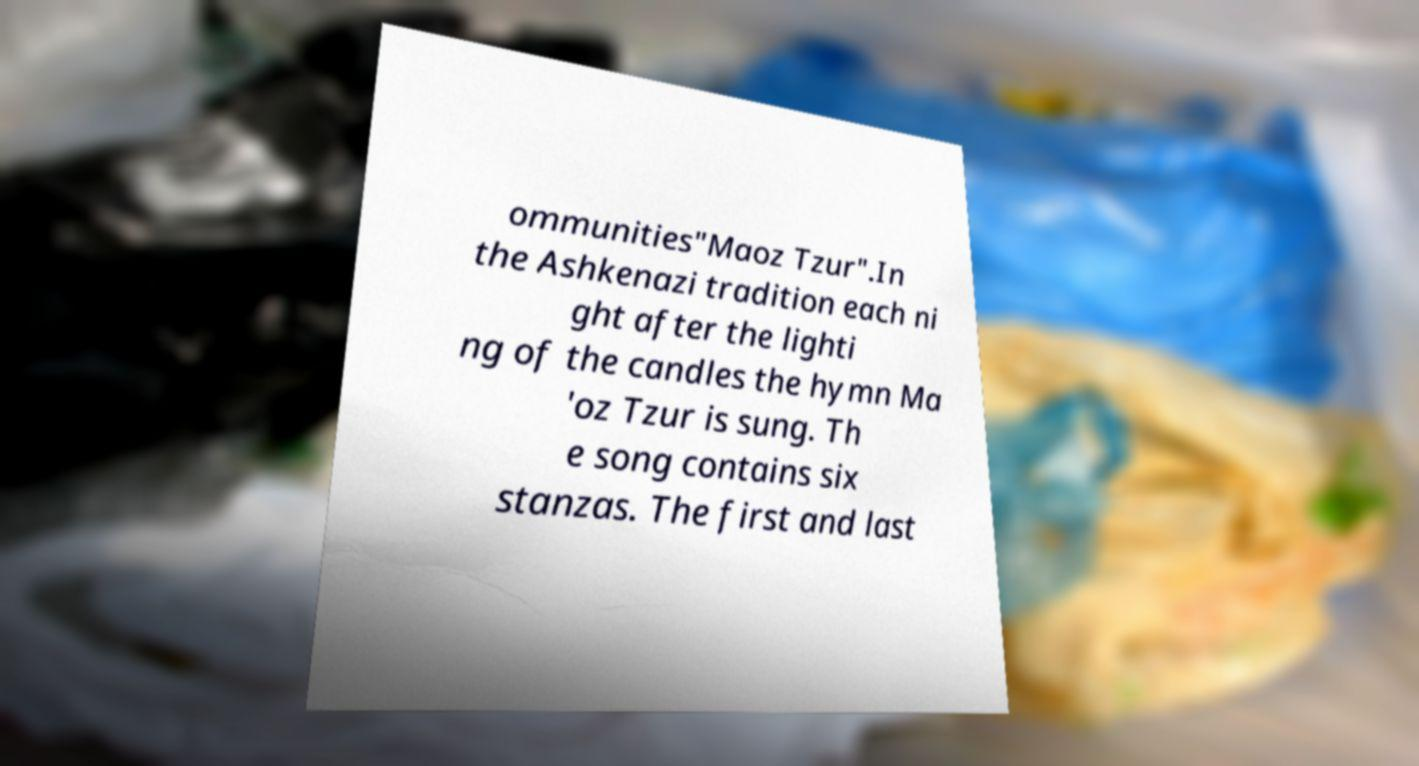Please identify and transcribe the text found in this image. ommunities"Maoz Tzur".In the Ashkenazi tradition each ni ght after the lighti ng of the candles the hymn Ma 'oz Tzur is sung. Th e song contains six stanzas. The first and last 